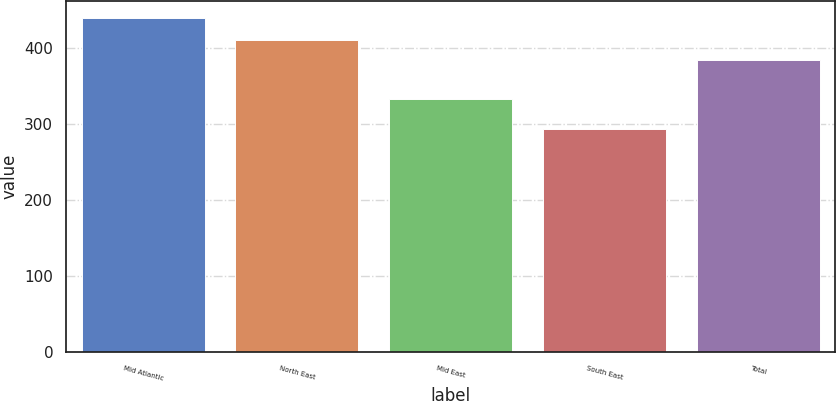Convert chart to OTSL. <chart><loc_0><loc_0><loc_500><loc_500><bar_chart><fcel>Mid Atlantic<fcel>North East<fcel>Mid East<fcel>South East<fcel>Total<nl><fcel>438.9<fcel>409.7<fcel>332.7<fcel>293.5<fcel>383.2<nl></chart> 